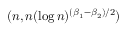Convert formula to latex. <formula><loc_0><loc_0><loc_500><loc_500>( n , n ( \log n ) ^ { ( \beta _ { 1 } - \beta _ { 2 } ) / 2 } )</formula> 